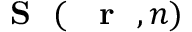Convert formula to latex. <formula><loc_0><loc_0><loc_500><loc_500>{ { S } } ( { r } , n )</formula> 